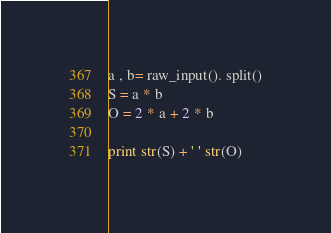<code> <loc_0><loc_0><loc_500><loc_500><_Python_>a , b= raw_input(). split()
S = a * b
O = 2 * a + 2 * b

print str(S) + ' ' str(O)</code> 